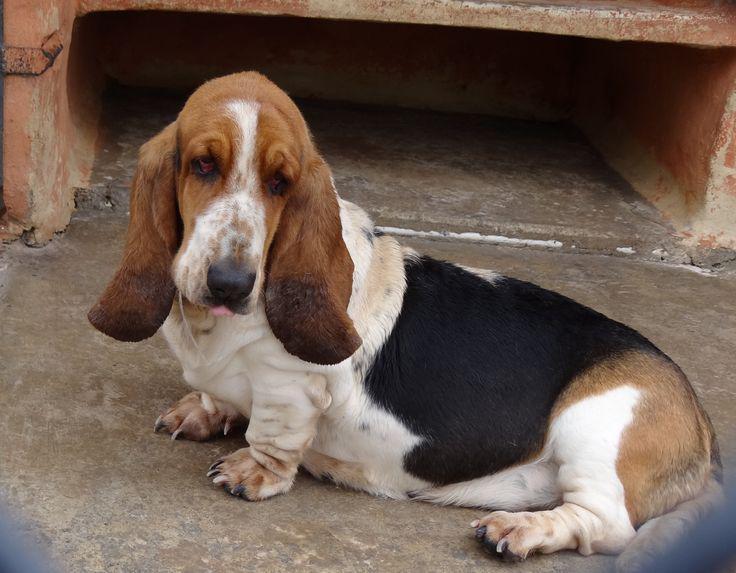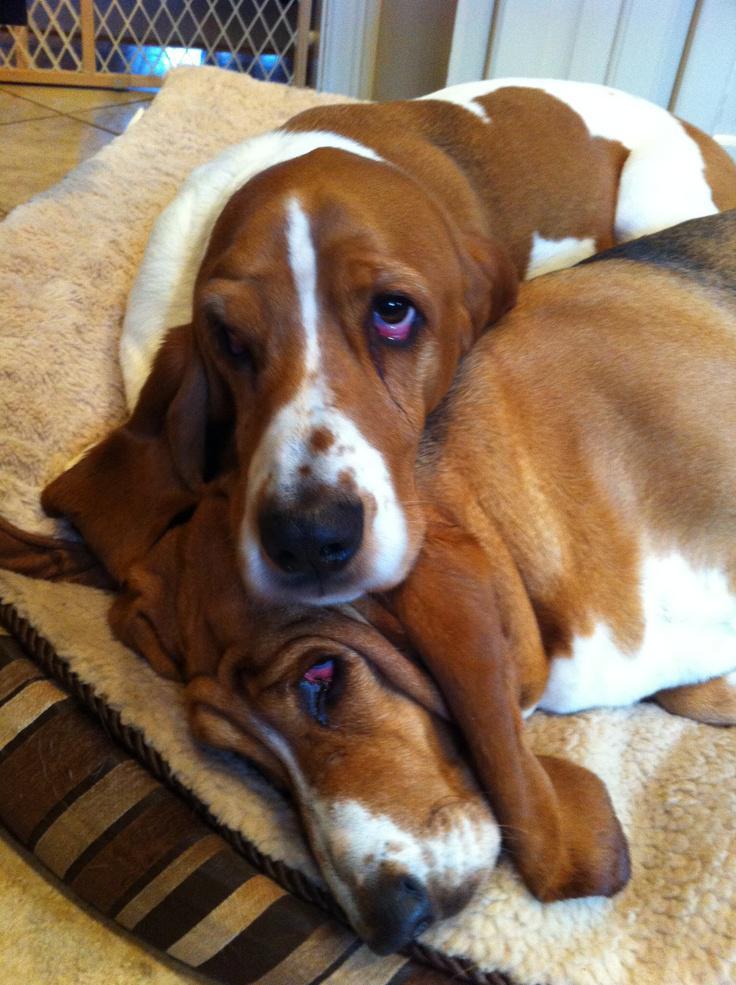The first image is the image on the left, the second image is the image on the right. For the images displayed, is the sentence "There is one hound in the left image and two hounds in the right image." factually correct? Answer yes or no. Yes. The first image is the image on the left, the second image is the image on the right. Given the left and right images, does the statement "There are three dogs that are not running." hold true? Answer yes or no. Yes. 